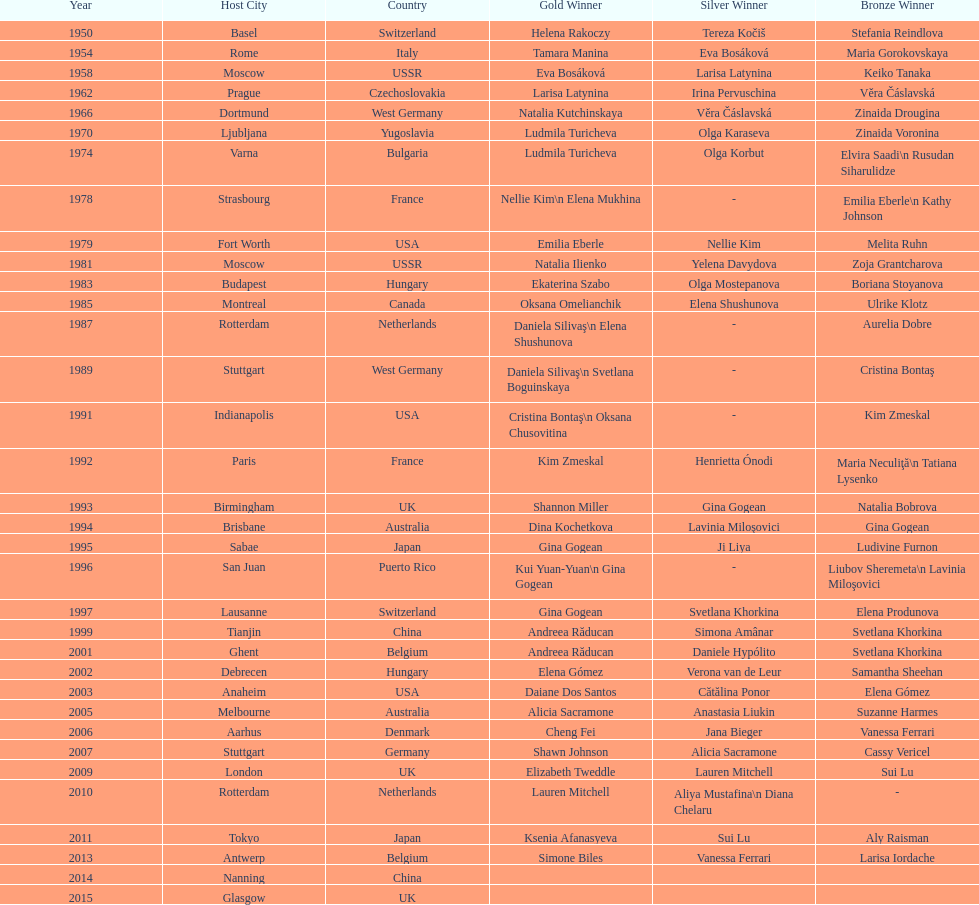How long is the time between the times the championship was held in moscow? 23 years. 